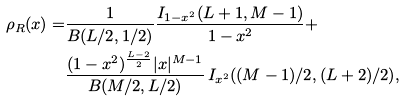<formula> <loc_0><loc_0><loc_500><loc_500>\rho _ { R } ( x ) = & \frac { 1 } { B ( { L } / { 2 } , { 1 } / { 2 } ) } \frac { I _ { 1 - x ^ { 2 } } ( L + 1 , M - 1 ) } { 1 - x ^ { 2 } } + \\ & \frac { ( 1 - x ^ { 2 } ) ^ { \frac { L - 2 } { 2 } } | x | ^ { M - 1 } } { B ( { M } / { 2 } , { L } / { 2 } ) } \, I _ { x ^ { 2 } } ( ( M - 1 ) / 2 , ( L + 2 ) / 2 ) ,</formula> 